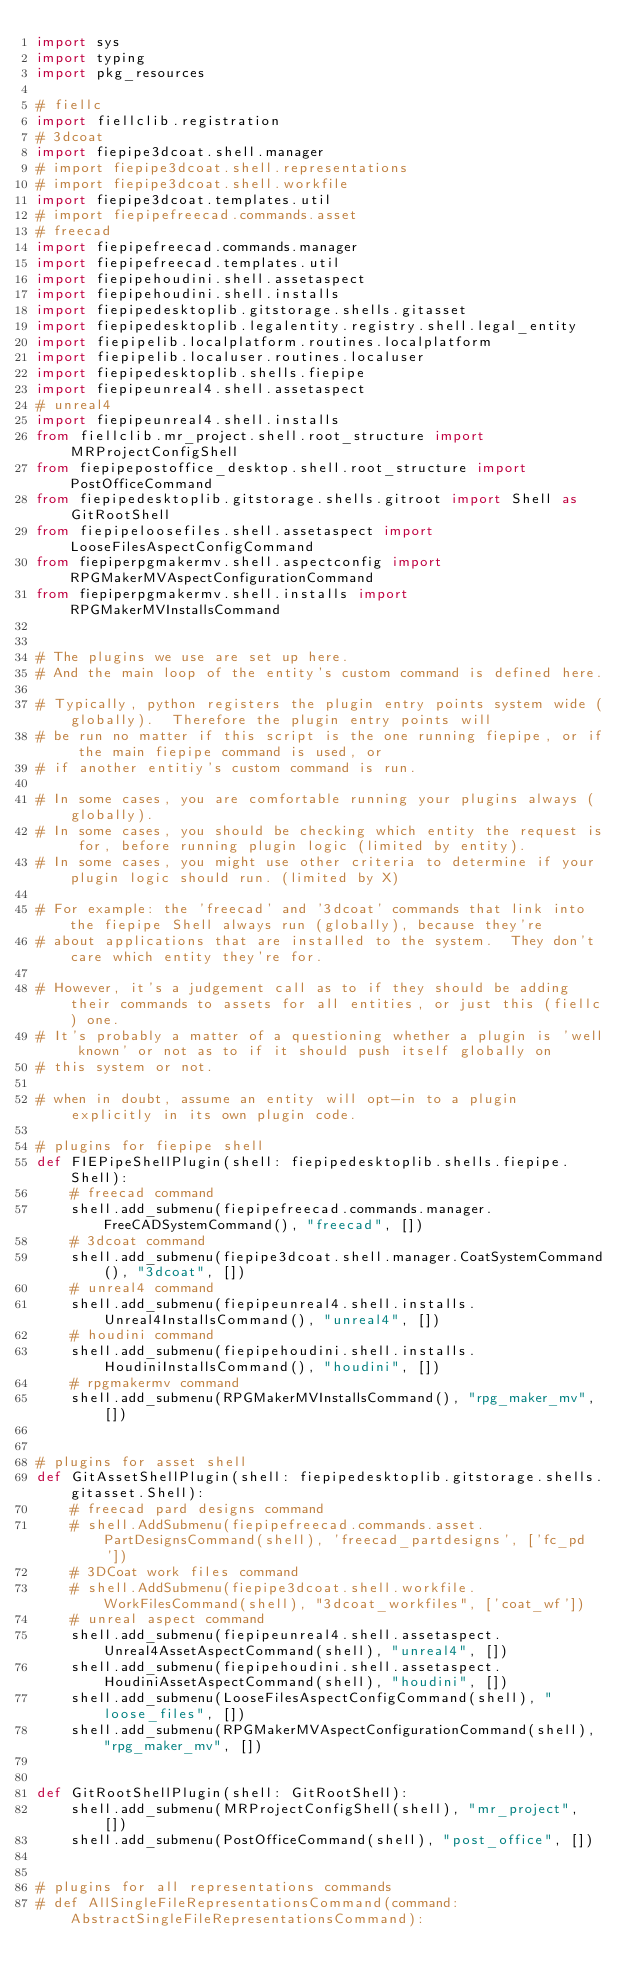Convert code to text. <code><loc_0><loc_0><loc_500><loc_500><_Python_>import sys
import typing
import pkg_resources

# fiellc
import fiellclib.registration
# 3dcoat
import fiepipe3dcoat.shell.manager
# import fiepipe3dcoat.shell.representations
# import fiepipe3dcoat.shell.workfile
import fiepipe3dcoat.templates.util
# import fiepipefreecad.commands.asset
# freecad
import fiepipefreecad.commands.manager
import fiepipefreecad.templates.util
import fiepipehoudini.shell.assetaspect
import fiepipehoudini.shell.installs
import fiepipedesktoplib.gitstorage.shells.gitasset
import fiepipedesktoplib.legalentity.registry.shell.legal_entity
import fiepipelib.localplatform.routines.localplatform
import fiepipelib.localuser.routines.localuser
import fiepipedesktoplib.shells.fiepipe
import fiepipeunreal4.shell.assetaspect
# unreal4
import fiepipeunreal4.shell.installs
from fiellclib.mr_project.shell.root_structure import MRProjectConfigShell
from fiepipepostoffice_desktop.shell.root_structure import PostOfficeCommand
from fiepipedesktoplib.gitstorage.shells.gitroot import Shell as GitRootShell
from fiepipeloosefiles.shell.assetaspect import LooseFilesAspectConfigCommand
from fiepiperpgmakermv.shell.aspectconfig import RPGMakerMVAspectConfigurationCommand
from fiepiperpgmakermv.shell.installs import RPGMakerMVInstallsCommand


# The plugins we use are set up here.
# And the main loop of the entity's custom command is defined here.

# Typically, python registers the plugin entry points system wide (globally).  Therefore the plugin entry points will
# be run no matter if this script is the one running fiepipe, or if the main fiepipe command is used, or
# if another entitiy's custom command is run.

# In some cases, you are comfortable running your plugins always (globally).
# In some cases, you should be checking which entity the request is for, before running plugin logic (limited by entity).
# In some cases, you might use other criteria to determine if your plugin logic should run. (limited by X)

# For example: the 'freecad' and '3dcoat' commands that link into the fiepipe Shell always run (globally), because they're
# about applications that are installed to the system.  They don't care which entity they're for.

# However, it's a judgement call as to if they should be adding their commands to assets for all entities, or just this (fiellc) one.
# It's probably a matter of a questioning whether a plugin is 'well known' or not as to if it should push itself globally on
# this system or not.

# when in doubt, assume an entity will opt-in to a plugin explicitly in its own plugin code.

# plugins for fiepipe shell
def FIEPipeShellPlugin(shell: fiepipedesktoplib.shells.fiepipe.Shell):
    # freecad command
    shell.add_submenu(fiepipefreecad.commands.manager.FreeCADSystemCommand(), "freecad", [])
    # 3dcoat command
    shell.add_submenu(fiepipe3dcoat.shell.manager.CoatSystemCommand(), "3dcoat", [])
    # unreal4 command
    shell.add_submenu(fiepipeunreal4.shell.installs.Unreal4InstallsCommand(), "unreal4", [])
    # houdini command
    shell.add_submenu(fiepipehoudini.shell.installs.HoudiniInstallsCommand(), "houdini", [])
    # rpgmakermv command
    shell.add_submenu(RPGMakerMVInstallsCommand(), "rpg_maker_mv", [])


# plugins for asset shell
def GitAssetShellPlugin(shell: fiepipedesktoplib.gitstorage.shells.gitasset.Shell):
    # freecad pard designs command
    # shell.AddSubmenu(fiepipefreecad.commands.asset.PartDesignsCommand(shell), 'freecad_partdesigns', ['fc_pd'])
    # 3DCoat work files command
    # shell.AddSubmenu(fiepipe3dcoat.shell.workfile.WorkFilesCommand(shell), "3dcoat_workfiles", ['coat_wf'])
    # unreal aspect command
    shell.add_submenu(fiepipeunreal4.shell.assetaspect.Unreal4AssetAspectCommand(shell), "unreal4", [])
    shell.add_submenu(fiepipehoudini.shell.assetaspect.HoudiniAssetAspectCommand(shell), "houdini", [])
    shell.add_submenu(LooseFilesAspectConfigCommand(shell), "loose_files", [])
    shell.add_submenu(RPGMakerMVAspectConfigurationCommand(shell), "rpg_maker_mv", [])


def GitRootShellPlugin(shell: GitRootShell):
    shell.add_submenu(MRProjectConfigShell(shell), "mr_project", [])
    shell.add_submenu(PostOfficeCommand(shell), "post_office", [])


# plugins for all representations commands
# def AllSingleFileRepresentationsCommand(command: AbstractSingleFileRepresentationsCommand):</code> 